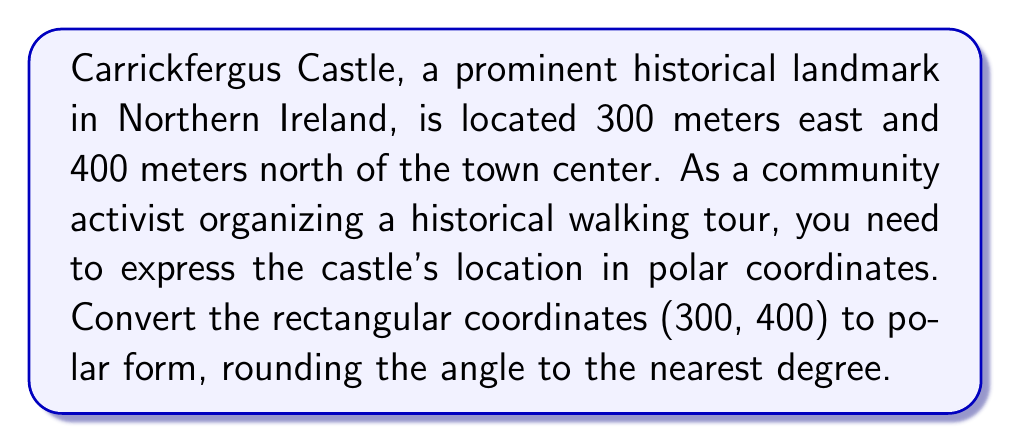Could you help me with this problem? To convert rectangular coordinates $(x, y)$ to polar coordinates $(r, \theta)$, we use the following formulas:

1. $r = \sqrt{x^2 + y^2}$
2. $\theta = \tan^{-1}(\frac{y}{x})$

Let's apply these steps:

1. Calculate $r$:
   $$r = \sqrt{300^2 + 400^2} = \sqrt{90,000 + 160,000} = \sqrt{250,000} = 500\text{ meters}$$

2. Calculate $\theta$:
   $$\theta = \tan^{-1}(\frac{400}{300}) \approx 53.13^\circ$$

   Rounding to the nearest degree: $53^\circ$

Note: The angle is measured counterclockwise from the positive x-axis (east in this case).

[asy]
import geometry;

size(200);
draw((-1,0)--(5,0),Arrow);
draw((0,-1)--(0,5),Arrow);
label("East", (5,0), E);
label("North", (0,5), N);
dot((3,4));
draw((0,0)--(3,4),Arrow);
label("Castle", (3,4), NE);
label("300m", (1.5,0), S);
label("400m", (3,2), E);
label("500m", (1.5,2), NW);
draw(arc((0,0),0.8,0,53),Arrow);
label("53°", (0.6,0.4));
</asy>

The polar coordinates consist of the distance from the origin (r) and the angle from the positive x-axis (θ).
Answer: $(500\text{ meters}, 53^\circ)$ 